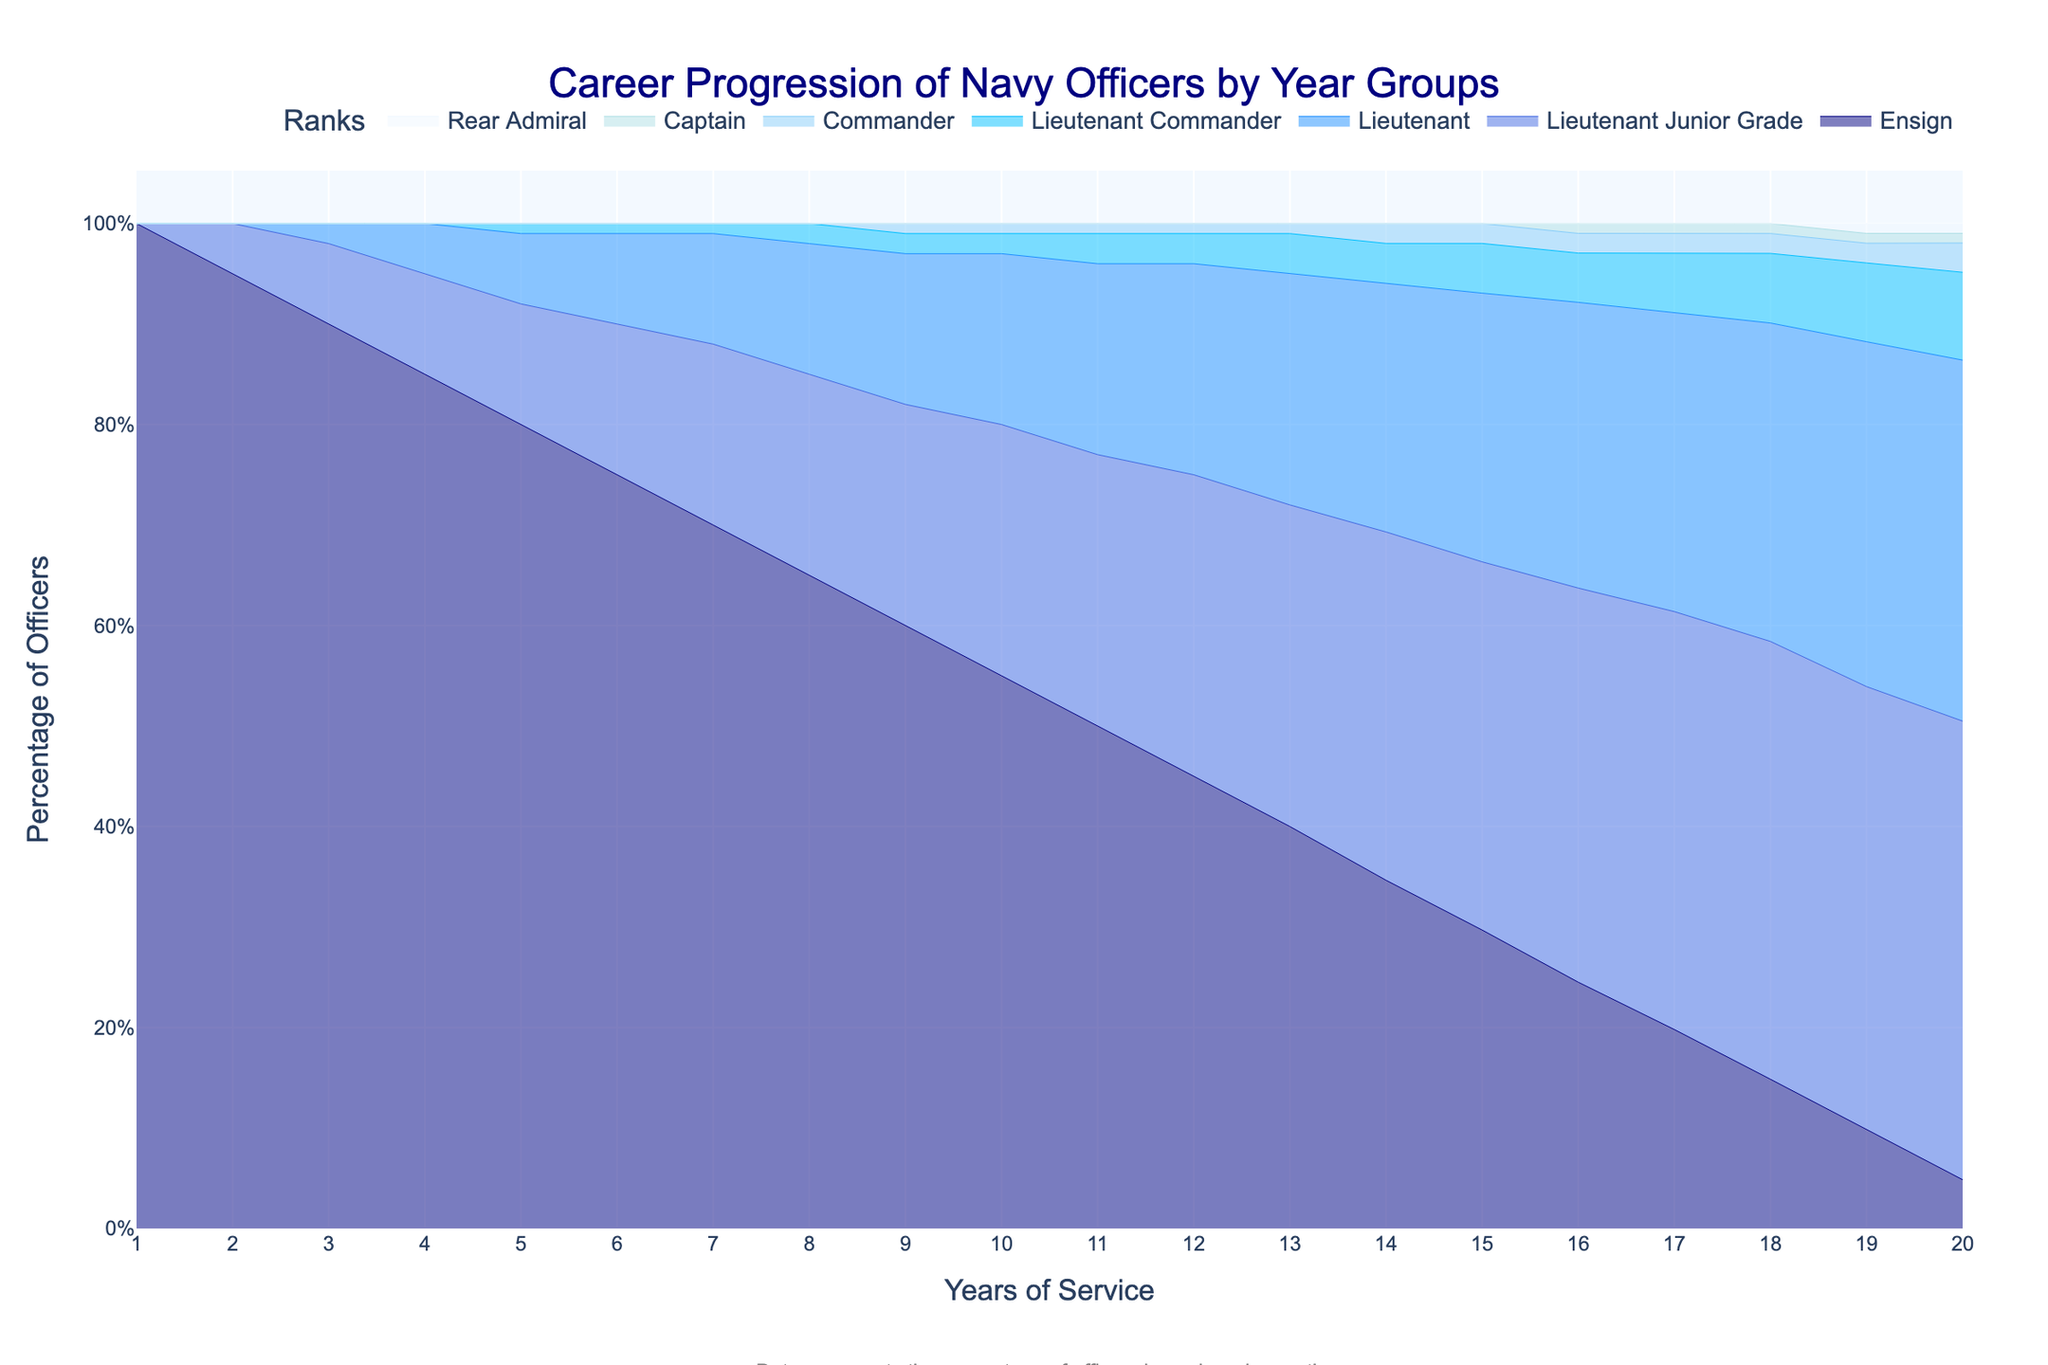What is the title of the chart? The title of the chart is displayed at the top center and reads 'Career Progression of Navy Officers by Year Groups'.
Answer: Career Progression of Navy Officers by Year Groups How does the percentage of Rear Admirals change over the years? The percentage of Rear Admirals begins at 0% and stays at 0% until the 19th year. In the 19th year, it ramps up to approximately 1% and continues at that level through the 20th year.
Answer: Starts at 0%, rises to 1% by the 19th year, and remains 1% Which rank has the highest percentage of officers at the beginning and how does it change over time? The Ensign rank has the highest percentage at the beginning (100%) and steadily decreases each year as officers get promoted. By the 20th year, only 5% of the officers are still in the Ensign rank.
Answer: Ensign; decreases from 100% to 5% Compare the percentage of Lieutenants and Commanders in the 10th year. Which one is higher and by how much? In the 10th year, Lieutenants make up 17% of the officers, while Commanders constitute 1%. Therefore, the percentage of Lieutenants is higher by 16%.
Answer: Lieutenants; higher by 16% What year does the chart show the first occurrence of Rear Admirals? The chart shows the first occurrence of Rear Admirals in the 19th year.
Answer: 19th year What is the proportion of Lieutenant Junior Grades and Lieutenants combined in the 15th year? In the 15th year, the percentage of Lieutenant Junior Grades is 37% and Lieutenants is 27%. The combined percentage is 37% + 27% = 64%.
Answer: 64% Which rank shows the most significant increase in percentage from the 1st to the 10th year? The Lieutenant Junior Grade starts at 0% in the 1st year and increases to 25% by the 10th year, indicating a 25% increase. This is the most significant increase among all ranks in that period.
Answer: Lieutenant Junior Grade How many years does it take for Captains to appear in the chart? Captains first appear in the chart in the 16th year.
Answer: 16 years In which year do all ranks except for Ensigns still have at least one officer present, and what is the percentage of Ensigns in that year? In the 20th year, all ranks except for Ensigns still have officers present. The percentage of Ensigns in this year is 5%.
Answer: 20th year; 5% Which rank has a consistent increase in its percentage from the 1st year to the 20th year? The Lieutenant Junior Grade rank shows a consistent increase in its percentage from 0% in the 1st year to 47% by the 20th year.
Answer: Lieutenant Junior Grade 